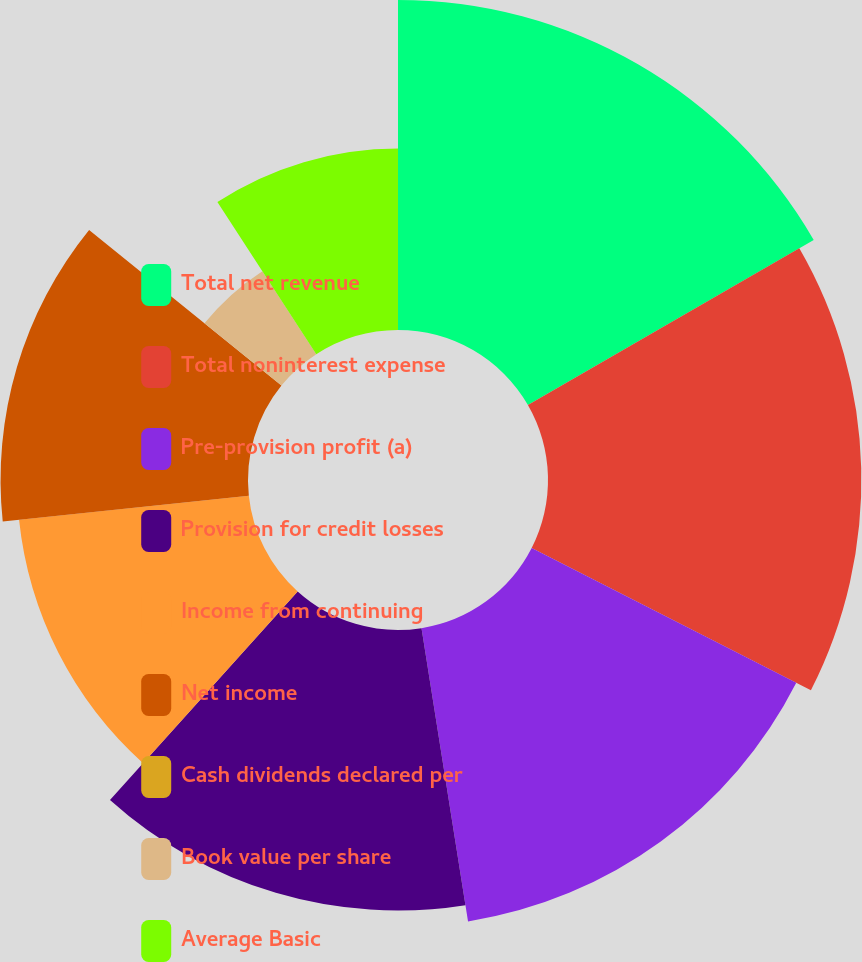<chart> <loc_0><loc_0><loc_500><loc_500><pie_chart><fcel>Total net revenue<fcel>Total noninterest expense<fcel>Pre-provision profit (a)<fcel>Provision for credit losses<fcel>Income from continuing<fcel>Net income<fcel>Cash dividends declared per<fcel>Book value per share<fcel>Average Basic<nl><fcel>16.67%<fcel>15.83%<fcel>15.0%<fcel>14.17%<fcel>11.67%<fcel>12.5%<fcel>0.0%<fcel>5.0%<fcel>9.17%<nl></chart> 